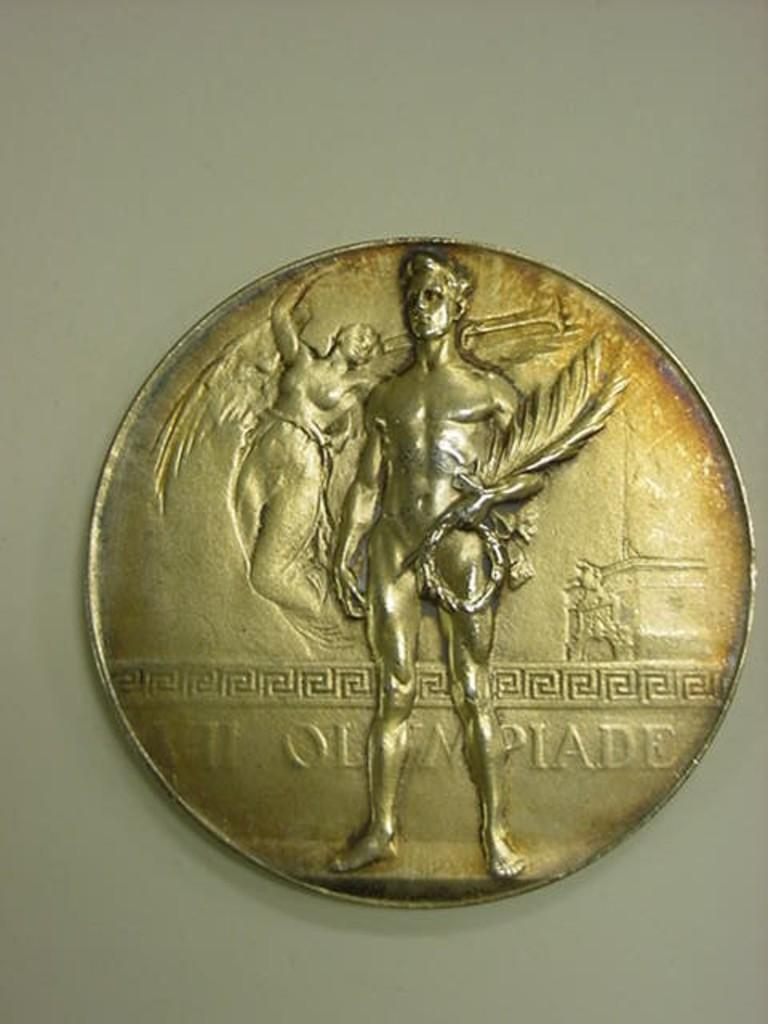<image>
Render a clear and concise summary of the photo. A medal from the 7th Olympiade is displayed on a white background. 